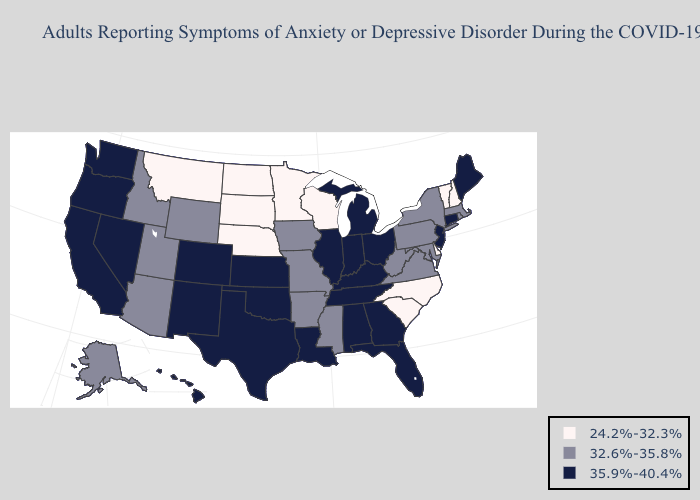Among the states that border Virginia , does Tennessee have the highest value?
Quick response, please. Yes. Does Pennsylvania have the lowest value in the USA?
Give a very brief answer. No. Among the states that border Kentucky , does West Virginia have the highest value?
Write a very short answer. No. Name the states that have a value in the range 24.2%-32.3%?
Answer briefly. Delaware, Minnesota, Montana, Nebraska, New Hampshire, North Carolina, North Dakota, South Carolina, South Dakota, Vermont, Wisconsin. Name the states that have a value in the range 24.2%-32.3%?
Be succinct. Delaware, Minnesota, Montana, Nebraska, New Hampshire, North Carolina, North Dakota, South Carolina, South Dakota, Vermont, Wisconsin. Does Indiana have the highest value in the MidWest?
Short answer required. Yes. What is the value of Ohio?
Give a very brief answer. 35.9%-40.4%. Does Kentucky have the same value as Rhode Island?
Short answer required. No. Is the legend a continuous bar?
Write a very short answer. No. What is the value of South Carolina?
Be succinct. 24.2%-32.3%. Name the states that have a value in the range 32.6%-35.8%?
Short answer required. Alaska, Arizona, Arkansas, Idaho, Iowa, Maryland, Massachusetts, Mississippi, Missouri, New York, Pennsylvania, Rhode Island, Utah, Virginia, West Virginia, Wyoming. Does North Dakota have the same value as Iowa?
Be succinct. No. Name the states that have a value in the range 24.2%-32.3%?
Write a very short answer. Delaware, Minnesota, Montana, Nebraska, New Hampshire, North Carolina, North Dakota, South Carolina, South Dakota, Vermont, Wisconsin. What is the lowest value in the MidWest?
Answer briefly. 24.2%-32.3%. Name the states that have a value in the range 32.6%-35.8%?
Be succinct. Alaska, Arizona, Arkansas, Idaho, Iowa, Maryland, Massachusetts, Mississippi, Missouri, New York, Pennsylvania, Rhode Island, Utah, Virginia, West Virginia, Wyoming. 